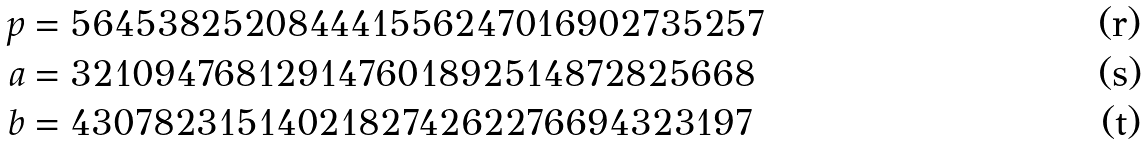<formula> <loc_0><loc_0><loc_500><loc_500>p & = 5 6 4 5 3 8 2 5 2 0 8 4 4 4 1 5 5 6 2 4 7 0 1 6 9 0 2 7 3 5 2 5 7 \\ a & = 3 2 1 0 9 4 7 6 8 1 2 9 1 4 7 6 0 1 8 9 2 5 1 4 8 7 2 8 2 5 6 6 8 \\ b & = 4 3 0 7 8 2 3 1 5 1 4 0 2 1 8 2 7 4 2 6 2 2 7 6 6 9 4 3 2 3 1 9 7</formula> 